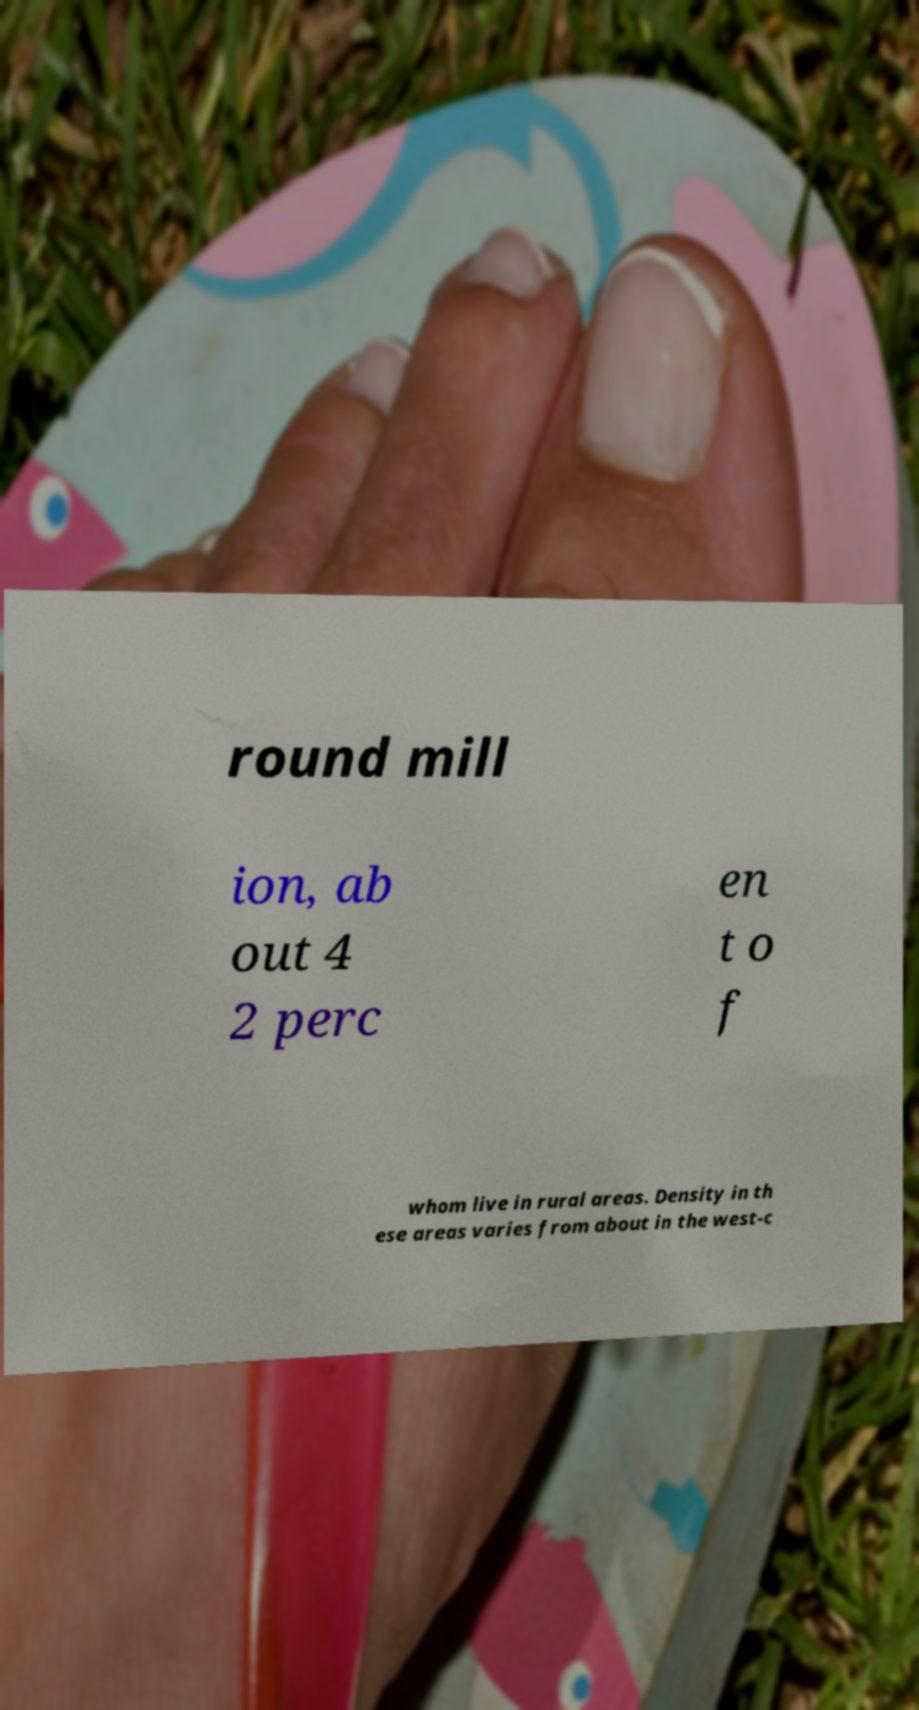There's text embedded in this image that I need extracted. Can you transcribe it verbatim? round mill ion, ab out 4 2 perc en t o f whom live in rural areas. Density in th ese areas varies from about in the west-c 